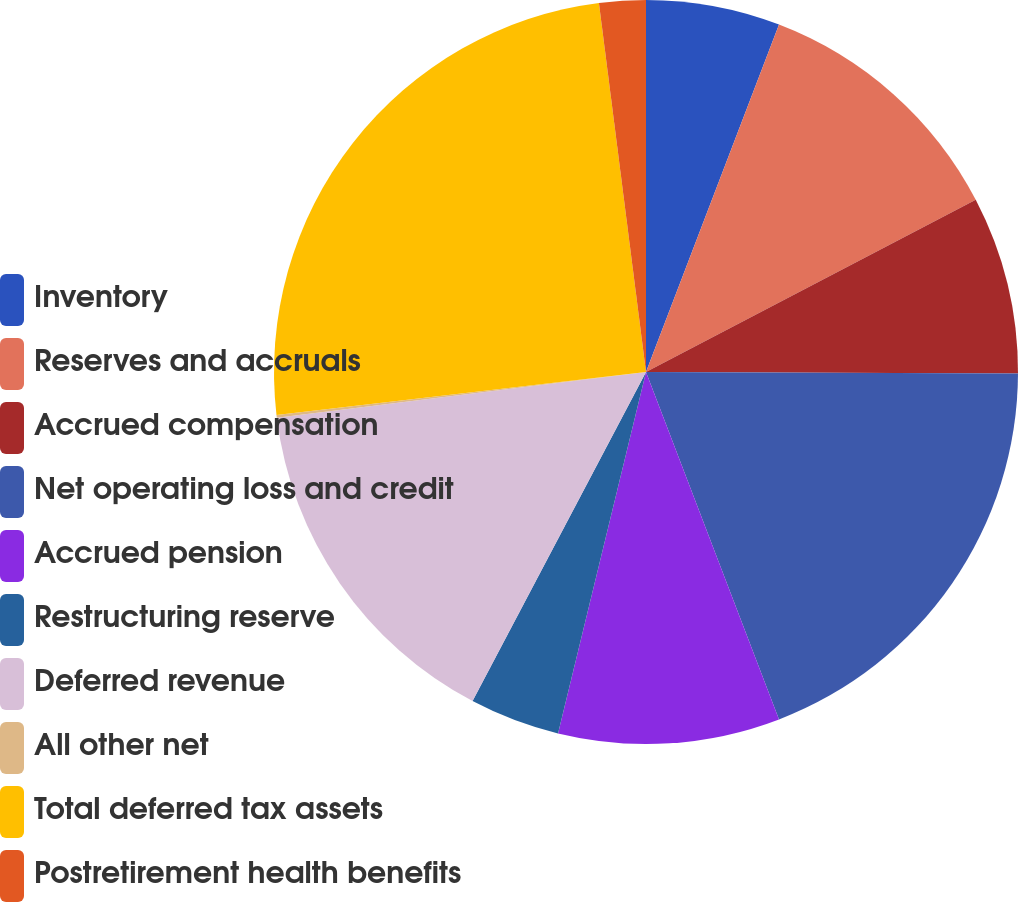<chart> <loc_0><loc_0><loc_500><loc_500><pie_chart><fcel>Inventory<fcel>Reserves and accruals<fcel>Accrued compensation<fcel>Net operating loss and credit<fcel>Accrued pension<fcel>Restructuring reserve<fcel>Deferred revenue<fcel>All other net<fcel>Total deferred tax assets<fcel>Postretirement health benefits<nl><fcel>5.82%<fcel>11.52%<fcel>7.72%<fcel>19.12%<fcel>9.62%<fcel>3.92%<fcel>15.32%<fcel>0.12%<fcel>24.82%<fcel>2.02%<nl></chart> 